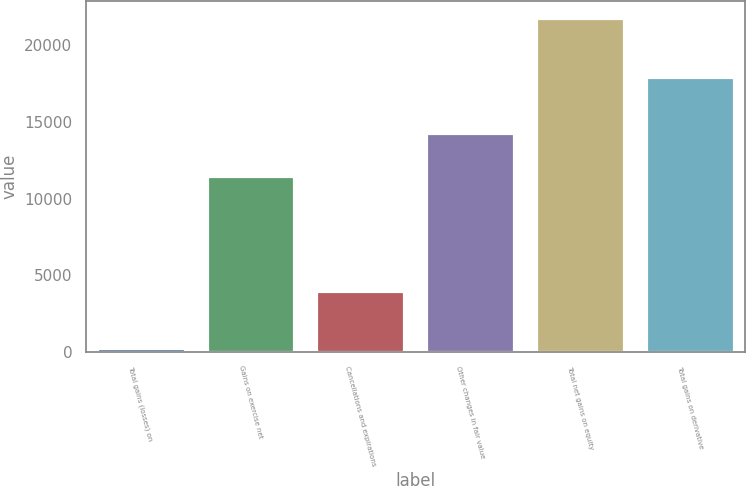<chart> <loc_0><loc_0><loc_500><loc_500><bar_chart><fcel>Total gains (losses) on<fcel>Gains on exercise net<fcel>Cancellations and expirations<fcel>Other changes in fair value<fcel>Total net gains on equity<fcel>Total gains on derivative<nl><fcel>219<fcel>11495<fcel>3963<fcel>14266<fcel>21798<fcel>17949<nl></chart> 